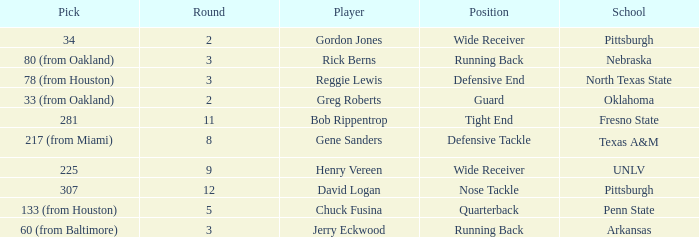What round was the nose tackle drafted? 12.0. 